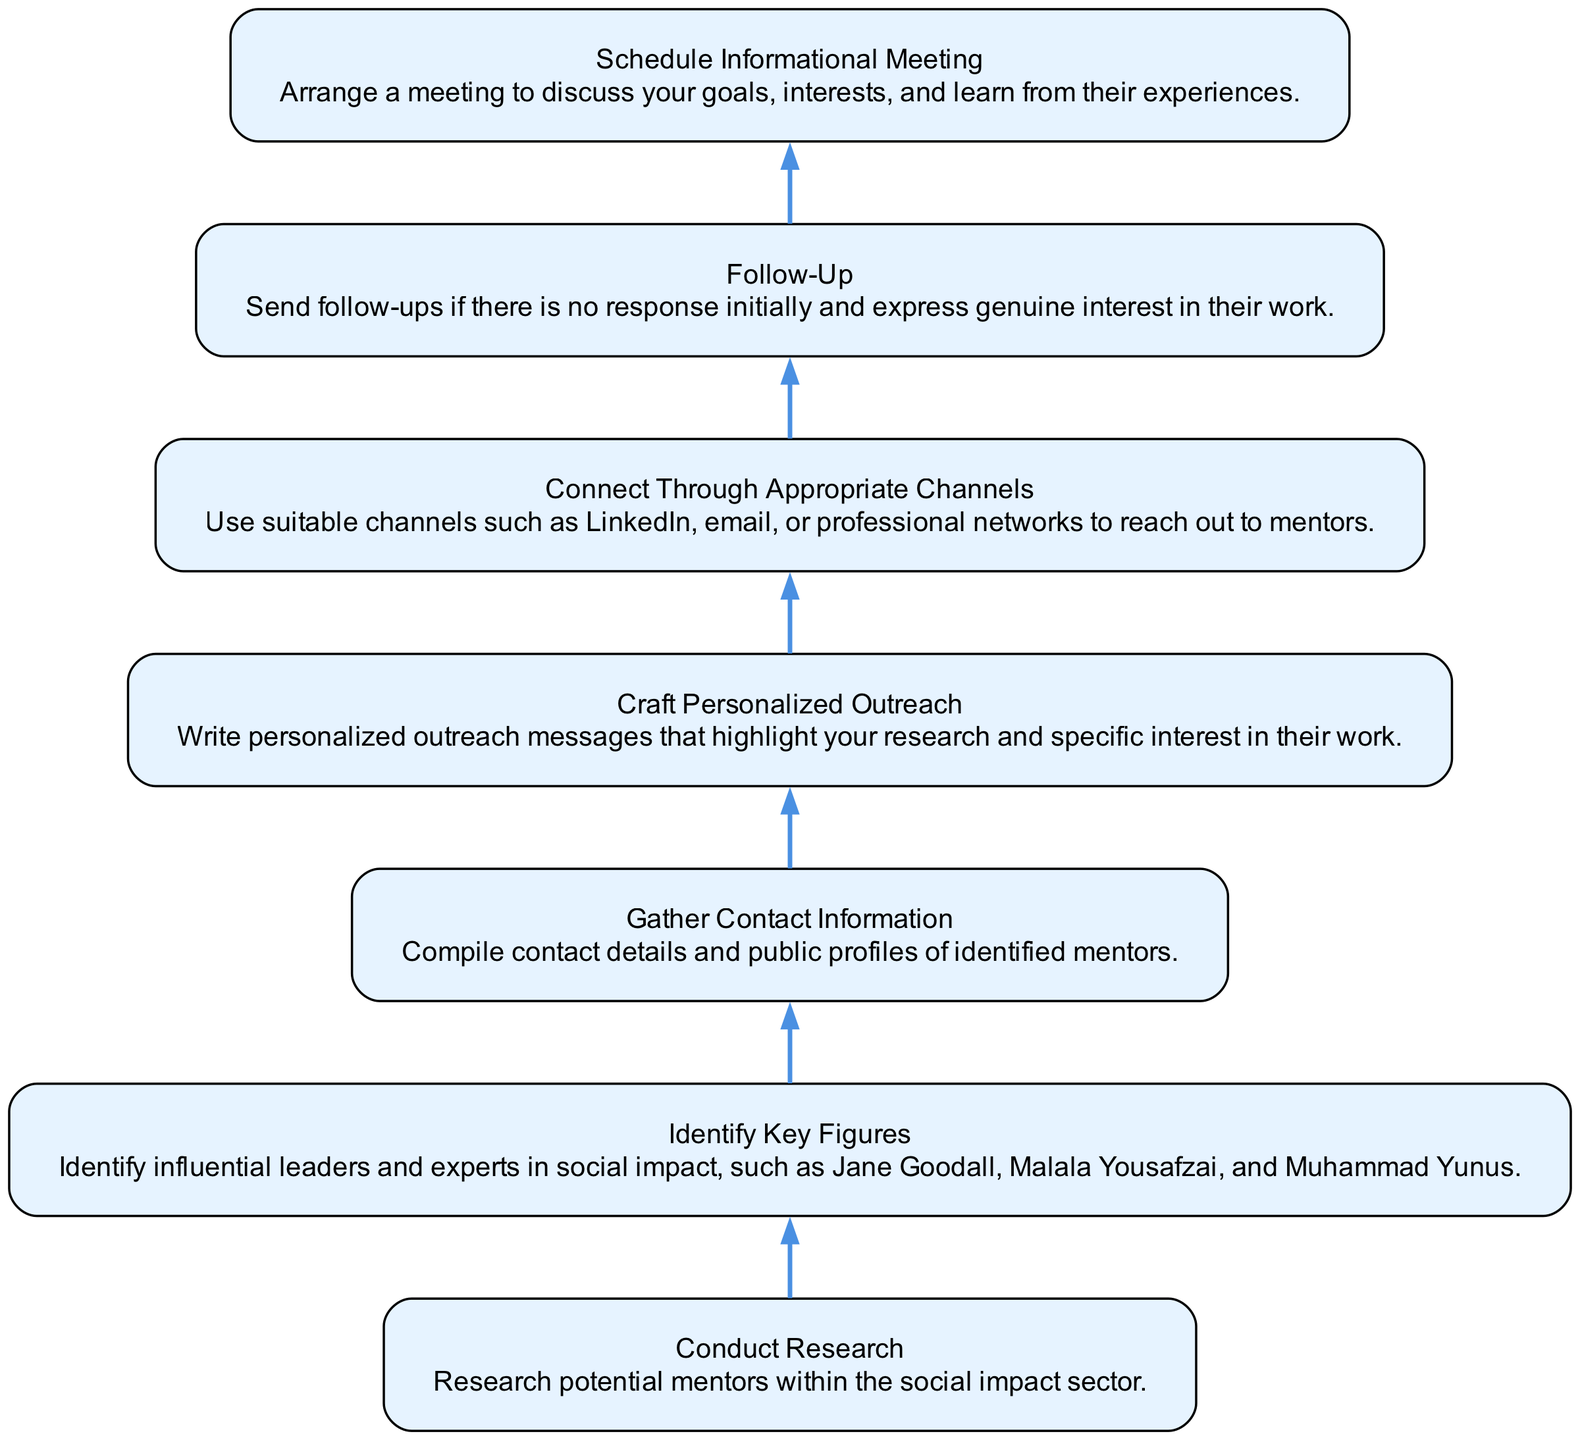What is the first step in the mentorship outreach strategy? The first step in the flowchart is "Conduct Research," which indicates that the process begins with researching potential mentors within the social impact sector.
Answer: Conduct Research How many key figures are identified in the strategy? The flowchart states that the step is to "Identify Key Figures," which suggests multiple influential leaders and experts, but does not specify a number. However, three examples are given: Jane Goodall, Malala Yousafzai, and Muhammad Yunus.
Answer: Multiple What is the last step in the mentorship outreach strategy? The final step in the flowchart is "Schedule Informational Meeting," which involves arranging a meeting to discuss goals and learn from experiences.
Answer: Schedule Informational Meeting What is the connection between gathering information and crafting personalized outreach? The diagram shows that after "Gather Contact Information," the next step is "Craft Personalized Outreach," indicating a direct flow from gathering information to creating outreach messages.
Answer: Craft Personalized Outreach How many total nodes are present in the diagram? By counting the distinct boxes in the flowchart, there are seven nodes, corresponding to each specific step in the mentorship outreach strategy.
Answer: Seven What information is required in the step "Gather Contact Information"? The description of this step specifies that it requires compiling contact details and public profiles of identified mentors, highlighting the importance of having their contact information ready.
Answer: Contact details What type of follow-up action does the process advise after initial outreach? The flowchart indicates a "Follow-Up" step, which emphasizes sending follow-ups if there is no response initially and expressing genuine interest in the mentors' work.
Answer: Follow-Up What are some suitable channels for connecting with mentors? The "Connect Through Appropriate Channels" step specifies suitable channels such as LinkedIn, email, or professional networks for outreach, pointing to modern methods of communication.
Answer: LinkedIn, email, professional networks 